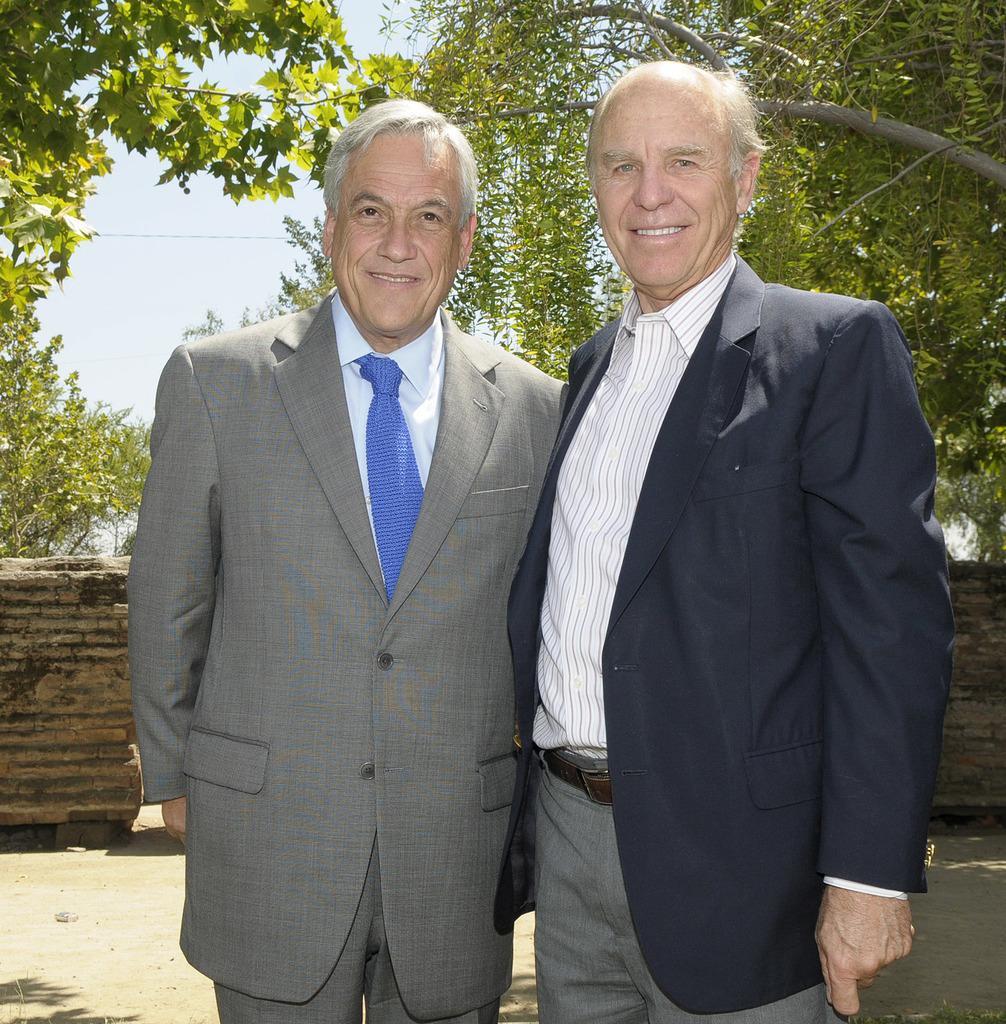In one or two sentences, can you explain what this image depicts? In this image I can see two men are standing and smiling. These men are wearing suits. In the background I can see trees, a wall and the sky. 